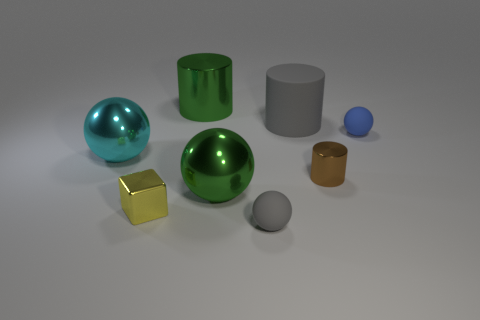What is the color of the tiny shiny thing that is on the left side of the gray thing that is in front of the tiny metallic block?
Your answer should be very brief. Yellow. What is the size of the yellow object that is made of the same material as the brown object?
Provide a succinct answer. Small. What number of gray matte objects have the same shape as the small brown metal thing?
Your answer should be very brief. 1. How many objects are either shiny blocks in front of the cyan ball or tiny things behind the metal block?
Keep it short and to the point. 3. How many small matte objects are in front of the large green sphere in front of the cyan object?
Offer a terse response. 1. Do the large green metal thing in front of the large green cylinder and the small rubber object left of the small blue matte ball have the same shape?
Give a very brief answer. Yes. What shape is the small rubber object that is the same color as the big rubber cylinder?
Offer a terse response. Sphere. Is there a big green object made of the same material as the big gray object?
Your response must be concise. No. How many metal things are small yellow cubes or big balls?
Make the answer very short. 3. There is a gray rubber object behind the tiny thing that is left of the green cylinder; what is its shape?
Your answer should be very brief. Cylinder. 